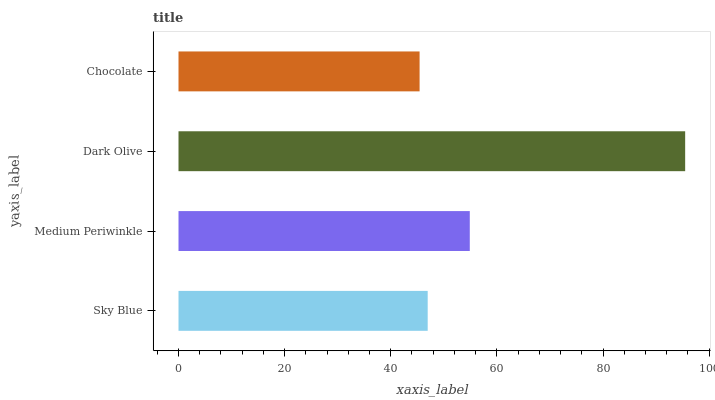Is Chocolate the minimum?
Answer yes or no. Yes. Is Dark Olive the maximum?
Answer yes or no. Yes. Is Medium Periwinkle the minimum?
Answer yes or no. No. Is Medium Periwinkle the maximum?
Answer yes or no. No. Is Medium Periwinkle greater than Sky Blue?
Answer yes or no. Yes. Is Sky Blue less than Medium Periwinkle?
Answer yes or no. Yes. Is Sky Blue greater than Medium Periwinkle?
Answer yes or no. No. Is Medium Periwinkle less than Sky Blue?
Answer yes or no. No. Is Medium Periwinkle the high median?
Answer yes or no. Yes. Is Sky Blue the low median?
Answer yes or no. Yes. Is Chocolate the high median?
Answer yes or no. No. Is Dark Olive the low median?
Answer yes or no. No. 